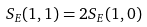<formula> <loc_0><loc_0><loc_500><loc_500>S _ { E } ( 1 , 1 ) = 2 S _ { E } ( 1 , 0 )</formula> 